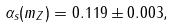Convert formula to latex. <formula><loc_0><loc_0><loc_500><loc_500>\alpha _ { s } ( m _ { Z } ) = 0 . 1 1 9 \pm 0 . 0 0 3 ,</formula> 